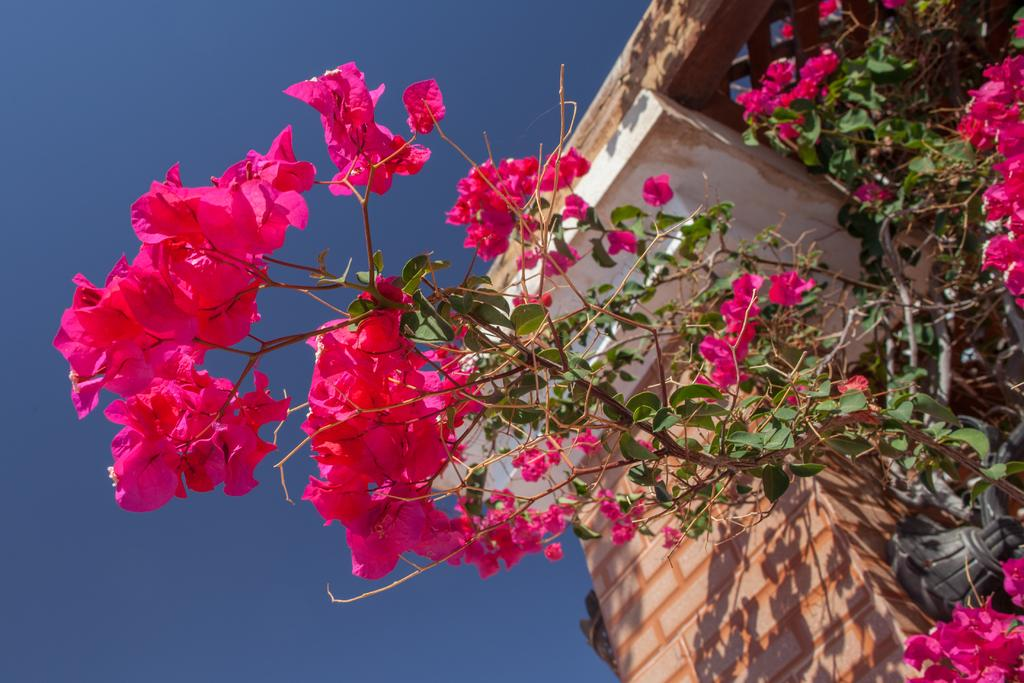What is present in the image that is related to nature? There is a plant in the image. What specific feature of the plant can be observed? The plant has flowers. What color are the flowers on the plant? The flowers are pink in color. What type of structure is visible in the image? There is a wall in the image. What can be seen in the background of the image? The sky is visible in the background of the image. What color is the sky in the image? The sky is blue in color. Where can the watch be found in the image? There is no watch present in the image. What type of store can be seen in the background of the image? There is no store visible in the image; it features a plant, a wall, and the sky. 